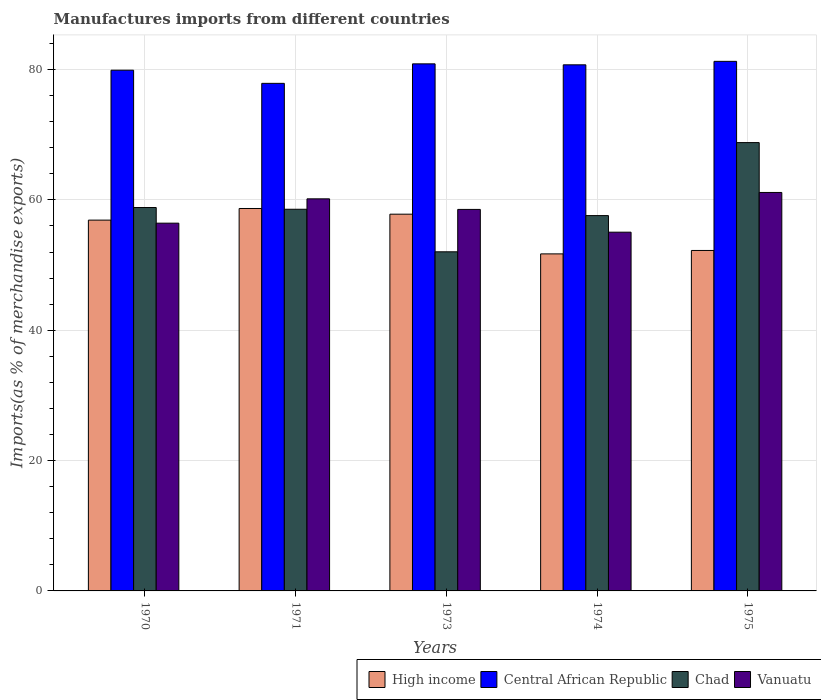How many different coloured bars are there?
Your answer should be compact. 4. Are the number of bars per tick equal to the number of legend labels?
Provide a succinct answer. Yes. How many bars are there on the 5th tick from the left?
Your answer should be compact. 4. What is the label of the 4th group of bars from the left?
Provide a short and direct response. 1974. In how many cases, is the number of bars for a given year not equal to the number of legend labels?
Give a very brief answer. 0. What is the percentage of imports to different countries in Vanuatu in 1973?
Give a very brief answer. 58.54. Across all years, what is the maximum percentage of imports to different countries in High income?
Make the answer very short. 58.69. Across all years, what is the minimum percentage of imports to different countries in Vanuatu?
Offer a terse response. 55.05. In which year was the percentage of imports to different countries in Chad maximum?
Give a very brief answer. 1975. What is the total percentage of imports to different countries in Central African Republic in the graph?
Your answer should be compact. 400.68. What is the difference between the percentage of imports to different countries in Central African Republic in 1973 and that in 1974?
Your answer should be compact. 0.15. What is the difference between the percentage of imports to different countries in High income in 1970 and the percentage of imports to different countries in Vanuatu in 1974?
Provide a succinct answer. 1.85. What is the average percentage of imports to different countries in Central African Republic per year?
Give a very brief answer. 80.14. In the year 1971, what is the difference between the percentage of imports to different countries in Central African Republic and percentage of imports to different countries in Vanuatu?
Make the answer very short. 17.72. In how many years, is the percentage of imports to different countries in Chad greater than 40 %?
Ensure brevity in your answer.  5. What is the ratio of the percentage of imports to different countries in Vanuatu in 1973 to that in 1975?
Provide a short and direct response. 0.96. Is the percentage of imports to different countries in Chad in 1974 less than that in 1975?
Keep it short and to the point. Yes. What is the difference between the highest and the second highest percentage of imports to different countries in High income?
Your answer should be very brief. 0.87. What is the difference between the highest and the lowest percentage of imports to different countries in Vanuatu?
Keep it short and to the point. 6.1. In how many years, is the percentage of imports to different countries in Vanuatu greater than the average percentage of imports to different countries in Vanuatu taken over all years?
Make the answer very short. 3. What does the 2nd bar from the left in 1970 represents?
Keep it short and to the point. Central African Republic. What does the 4th bar from the right in 1971 represents?
Provide a short and direct response. High income. Are all the bars in the graph horizontal?
Your answer should be very brief. No. How many years are there in the graph?
Make the answer very short. 5. What is the difference between two consecutive major ticks on the Y-axis?
Your answer should be very brief. 20. Does the graph contain grids?
Ensure brevity in your answer.  Yes. How many legend labels are there?
Provide a short and direct response. 4. What is the title of the graph?
Keep it short and to the point. Manufactures imports from different countries. Does "Middle income" appear as one of the legend labels in the graph?
Offer a terse response. No. What is the label or title of the Y-axis?
Your answer should be very brief. Imports(as % of merchandise exports). What is the Imports(as % of merchandise exports) in High income in 1970?
Keep it short and to the point. 56.9. What is the Imports(as % of merchandise exports) in Central African Republic in 1970?
Offer a very short reply. 79.91. What is the Imports(as % of merchandise exports) in Chad in 1970?
Give a very brief answer. 58.84. What is the Imports(as % of merchandise exports) of Vanuatu in 1970?
Provide a short and direct response. 56.43. What is the Imports(as % of merchandise exports) in High income in 1971?
Provide a short and direct response. 58.69. What is the Imports(as % of merchandise exports) of Central African Republic in 1971?
Keep it short and to the point. 77.89. What is the Imports(as % of merchandise exports) of Chad in 1971?
Give a very brief answer. 58.57. What is the Imports(as % of merchandise exports) in Vanuatu in 1971?
Your response must be concise. 60.17. What is the Imports(as % of merchandise exports) of High income in 1973?
Your answer should be very brief. 57.81. What is the Imports(as % of merchandise exports) of Central African Republic in 1973?
Offer a very short reply. 80.88. What is the Imports(as % of merchandise exports) of Chad in 1973?
Offer a very short reply. 52.04. What is the Imports(as % of merchandise exports) in Vanuatu in 1973?
Your answer should be compact. 58.54. What is the Imports(as % of merchandise exports) of High income in 1974?
Your answer should be very brief. 51.72. What is the Imports(as % of merchandise exports) in Central African Republic in 1974?
Your answer should be compact. 80.73. What is the Imports(as % of merchandise exports) in Chad in 1974?
Your answer should be compact. 57.59. What is the Imports(as % of merchandise exports) in Vanuatu in 1974?
Give a very brief answer. 55.05. What is the Imports(as % of merchandise exports) of High income in 1975?
Your answer should be compact. 52.24. What is the Imports(as % of merchandise exports) in Central African Republic in 1975?
Your answer should be compact. 81.27. What is the Imports(as % of merchandise exports) in Chad in 1975?
Provide a short and direct response. 68.8. What is the Imports(as % of merchandise exports) of Vanuatu in 1975?
Keep it short and to the point. 61.15. Across all years, what is the maximum Imports(as % of merchandise exports) of High income?
Provide a short and direct response. 58.69. Across all years, what is the maximum Imports(as % of merchandise exports) of Central African Republic?
Your answer should be very brief. 81.27. Across all years, what is the maximum Imports(as % of merchandise exports) in Chad?
Ensure brevity in your answer.  68.8. Across all years, what is the maximum Imports(as % of merchandise exports) in Vanuatu?
Provide a short and direct response. 61.15. Across all years, what is the minimum Imports(as % of merchandise exports) of High income?
Make the answer very short. 51.72. Across all years, what is the minimum Imports(as % of merchandise exports) of Central African Republic?
Make the answer very short. 77.89. Across all years, what is the minimum Imports(as % of merchandise exports) of Chad?
Offer a terse response. 52.04. Across all years, what is the minimum Imports(as % of merchandise exports) of Vanuatu?
Provide a short and direct response. 55.05. What is the total Imports(as % of merchandise exports) of High income in the graph?
Provide a succinct answer. 277.37. What is the total Imports(as % of merchandise exports) of Central African Republic in the graph?
Your response must be concise. 400.68. What is the total Imports(as % of merchandise exports) in Chad in the graph?
Provide a short and direct response. 295.84. What is the total Imports(as % of merchandise exports) of Vanuatu in the graph?
Your answer should be very brief. 291.34. What is the difference between the Imports(as % of merchandise exports) of High income in 1970 and that in 1971?
Provide a short and direct response. -1.78. What is the difference between the Imports(as % of merchandise exports) of Central African Republic in 1970 and that in 1971?
Make the answer very short. 2.02. What is the difference between the Imports(as % of merchandise exports) of Chad in 1970 and that in 1971?
Offer a very short reply. 0.27. What is the difference between the Imports(as % of merchandise exports) in Vanuatu in 1970 and that in 1971?
Your answer should be very brief. -3.73. What is the difference between the Imports(as % of merchandise exports) in High income in 1970 and that in 1973?
Your answer should be compact. -0.91. What is the difference between the Imports(as % of merchandise exports) in Central African Republic in 1970 and that in 1973?
Make the answer very short. -0.97. What is the difference between the Imports(as % of merchandise exports) of Chad in 1970 and that in 1973?
Make the answer very short. 6.8. What is the difference between the Imports(as % of merchandise exports) of Vanuatu in 1970 and that in 1973?
Keep it short and to the point. -2.11. What is the difference between the Imports(as % of merchandise exports) in High income in 1970 and that in 1974?
Your answer should be very brief. 5.18. What is the difference between the Imports(as % of merchandise exports) in Central African Republic in 1970 and that in 1974?
Make the answer very short. -0.82. What is the difference between the Imports(as % of merchandise exports) of Chad in 1970 and that in 1974?
Your answer should be very brief. 1.24. What is the difference between the Imports(as % of merchandise exports) in Vanuatu in 1970 and that in 1974?
Your answer should be compact. 1.38. What is the difference between the Imports(as % of merchandise exports) in High income in 1970 and that in 1975?
Ensure brevity in your answer.  4.66. What is the difference between the Imports(as % of merchandise exports) in Central African Republic in 1970 and that in 1975?
Your response must be concise. -1.36. What is the difference between the Imports(as % of merchandise exports) in Chad in 1970 and that in 1975?
Give a very brief answer. -9.96. What is the difference between the Imports(as % of merchandise exports) in Vanuatu in 1970 and that in 1975?
Your response must be concise. -4.71. What is the difference between the Imports(as % of merchandise exports) of High income in 1971 and that in 1973?
Your answer should be compact. 0.87. What is the difference between the Imports(as % of merchandise exports) of Central African Republic in 1971 and that in 1973?
Offer a very short reply. -2.99. What is the difference between the Imports(as % of merchandise exports) in Chad in 1971 and that in 1973?
Make the answer very short. 6.53. What is the difference between the Imports(as % of merchandise exports) in Vanuatu in 1971 and that in 1973?
Ensure brevity in your answer.  1.62. What is the difference between the Imports(as % of merchandise exports) of High income in 1971 and that in 1974?
Keep it short and to the point. 6.97. What is the difference between the Imports(as % of merchandise exports) in Central African Republic in 1971 and that in 1974?
Your response must be concise. -2.84. What is the difference between the Imports(as % of merchandise exports) in Chad in 1971 and that in 1974?
Provide a short and direct response. 0.97. What is the difference between the Imports(as % of merchandise exports) in Vanuatu in 1971 and that in 1974?
Your answer should be very brief. 5.12. What is the difference between the Imports(as % of merchandise exports) of High income in 1971 and that in 1975?
Make the answer very short. 6.44. What is the difference between the Imports(as % of merchandise exports) in Central African Republic in 1971 and that in 1975?
Provide a short and direct response. -3.38. What is the difference between the Imports(as % of merchandise exports) of Chad in 1971 and that in 1975?
Make the answer very short. -10.23. What is the difference between the Imports(as % of merchandise exports) of Vanuatu in 1971 and that in 1975?
Provide a short and direct response. -0.98. What is the difference between the Imports(as % of merchandise exports) of High income in 1973 and that in 1974?
Provide a succinct answer. 6.09. What is the difference between the Imports(as % of merchandise exports) in Central African Republic in 1973 and that in 1974?
Offer a terse response. 0.15. What is the difference between the Imports(as % of merchandise exports) of Chad in 1973 and that in 1974?
Offer a terse response. -5.55. What is the difference between the Imports(as % of merchandise exports) of Vanuatu in 1973 and that in 1974?
Give a very brief answer. 3.49. What is the difference between the Imports(as % of merchandise exports) in High income in 1973 and that in 1975?
Your answer should be compact. 5.57. What is the difference between the Imports(as % of merchandise exports) of Central African Republic in 1973 and that in 1975?
Make the answer very short. -0.38. What is the difference between the Imports(as % of merchandise exports) in Chad in 1973 and that in 1975?
Offer a very short reply. -16.76. What is the difference between the Imports(as % of merchandise exports) of Vanuatu in 1973 and that in 1975?
Offer a terse response. -2.6. What is the difference between the Imports(as % of merchandise exports) in High income in 1974 and that in 1975?
Give a very brief answer. -0.53. What is the difference between the Imports(as % of merchandise exports) of Central African Republic in 1974 and that in 1975?
Your answer should be very brief. -0.53. What is the difference between the Imports(as % of merchandise exports) of Chad in 1974 and that in 1975?
Provide a short and direct response. -11.2. What is the difference between the Imports(as % of merchandise exports) in Vanuatu in 1974 and that in 1975?
Your answer should be very brief. -6.1. What is the difference between the Imports(as % of merchandise exports) in High income in 1970 and the Imports(as % of merchandise exports) in Central African Republic in 1971?
Your response must be concise. -20.99. What is the difference between the Imports(as % of merchandise exports) in High income in 1970 and the Imports(as % of merchandise exports) in Chad in 1971?
Keep it short and to the point. -1.67. What is the difference between the Imports(as % of merchandise exports) in High income in 1970 and the Imports(as % of merchandise exports) in Vanuatu in 1971?
Provide a succinct answer. -3.26. What is the difference between the Imports(as % of merchandise exports) of Central African Republic in 1970 and the Imports(as % of merchandise exports) of Chad in 1971?
Your answer should be very brief. 21.34. What is the difference between the Imports(as % of merchandise exports) in Central African Republic in 1970 and the Imports(as % of merchandise exports) in Vanuatu in 1971?
Give a very brief answer. 19.74. What is the difference between the Imports(as % of merchandise exports) in Chad in 1970 and the Imports(as % of merchandise exports) in Vanuatu in 1971?
Provide a short and direct response. -1.33. What is the difference between the Imports(as % of merchandise exports) in High income in 1970 and the Imports(as % of merchandise exports) in Central African Republic in 1973?
Your answer should be compact. -23.98. What is the difference between the Imports(as % of merchandise exports) of High income in 1970 and the Imports(as % of merchandise exports) of Chad in 1973?
Keep it short and to the point. 4.86. What is the difference between the Imports(as % of merchandise exports) in High income in 1970 and the Imports(as % of merchandise exports) in Vanuatu in 1973?
Ensure brevity in your answer.  -1.64. What is the difference between the Imports(as % of merchandise exports) in Central African Republic in 1970 and the Imports(as % of merchandise exports) in Chad in 1973?
Provide a short and direct response. 27.87. What is the difference between the Imports(as % of merchandise exports) in Central African Republic in 1970 and the Imports(as % of merchandise exports) in Vanuatu in 1973?
Provide a short and direct response. 21.37. What is the difference between the Imports(as % of merchandise exports) of Chad in 1970 and the Imports(as % of merchandise exports) of Vanuatu in 1973?
Your answer should be compact. 0.29. What is the difference between the Imports(as % of merchandise exports) in High income in 1970 and the Imports(as % of merchandise exports) in Central African Republic in 1974?
Provide a short and direct response. -23.83. What is the difference between the Imports(as % of merchandise exports) of High income in 1970 and the Imports(as % of merchandise exports) of Chad in 1974?
Provide a short and direct response. -0.69. What is the difference between the Imports(as % of merchandise exports) in High income in 1970 and the Imports(as % of merchandise exports) in Vanuatu in 1974?
Provide a succinct answer. 1.85. What is the difference between the Imports(as % of merchandise exports) of Central African Republic in 1970 and the Imports(as % of merchandise exports) of Chad in 1974?
Make the answer very short. 22.31. What is the difference between the Imports(as % of merchandise exports) of Central African Republic in 1970 and the Imports(as % of merchandise exports) of Vanuatu in 1974?
Make the answer very short. 24.86. What is the difference between the Imports(as % of merchandise exports) of Chad in 1970 and the Imports(as % of merchandise exports) of Vanuatu in 1974?
Offer a very short reply. 3.79. What is the difference between the Imports(as % of merchandise exports) in High income in 1970 and the Imports(as % of merchandise exports) in Central African Republic in 1975?
Your response must be concise. -24.36. What is the difference between the Imports(as % of merchandise exports) of High income in 1970 and the Imports(as % of merchandise exports) of Chad in 1975?
Provide a succinct answer. -11.89. What is the difference between the Imports(as % of merchandise exports) of High income in 1970 and the Imports(as % of merchandise exports) of Vanuatu in 1975?
Provide a short and direct response. -4.24. What is the difference between the Imports(as % of merchandise exports) of Central African Republic in 1970 and the Imports(as % of merchandise exports) of Chad in 1975?
Your response must be concise. 11.11. What is the difference between the Imports(as % of merchandise exports) of Central African Republic in 1970 and the Imports(as % of merchandise exports) of Vanuatu in 1975?
Make the answer very short. 18.76. What is the difference between the Imports(as % of merchandise exports) in Chad in 1970 and the Imports(as % of merchandise exports) in Vanuatu in 1975?
Your answer should be compact. -2.31. What is the difference between the Imports(as % of merchandise exports) in High income in 1971 and the Imports(as % of merchandise exports) in Central African Republic in 1973?
Provide a short and direct response. -22.2. What is the difference between the Imports(as % of merchandise exports) of High income in 1971 and the Imports(as % of merchandise exports) of Chad in 1973?
Your response must be concise. 6.65. What is the difference between the Imports(as % of merchandise exports) of High income in 1971 and the Imports(as % of merchandise exports) of Vanuatu in 1973?
Give a very brief answer. 0.14. What is the difference between the Imports(as % of merchandise exports) in Central African Republic in 1971 and the Imports(as % of merchandise exports) in Chad in 1973?
Give a very brief answer. 25.85. What is the difference between the Imports(as % of merchandise exports) in Central African Republic in 1971 and the Imports(as % of merchandise exports) in Vanuatu in 1973?
Give a very brief answer. 19.35. What is the difference between the Imports(as % of merchandise exports) in Chad in 1971 and the Imports(as % of merchandise exports) in Vanuatu in 1973?
Your answer should be compact. 0.03. What is the difference between the Imports(as % of merchandise exports) of High income in 1971 and the Imports(as % of merchandise exports) of Central African Republic in 1974?
Make the answer very short. -22.05. What is the difference between the Imports(as % of merchandise exports) in High income in 1971 and the Imports(as % of merchandise exports) in Chad in 1974?
Your answer should be compact. 1.09. What is the difference between the Imports(as % of merchandise exports) in High income in 1971 and the Imports(as % of merchandise exports) in Vanuatu in 1974?
Your answer should be very brief. 3.64. What is the difference between the Imports(as % of merchandise exports) of Central African Republic in 1971 and the Imports(as % of merchandise exports) of Chad in 1974?
Ensure brevity in your answer.  20.29. What is the difference between the Imports(as % of merchandise exports) of Central African Republic in 1971 and the Imports(as % of merchandise exports) of Vanuatu in 1974?
Provide a short and direct response. 22.84. What is the difference between the Imports(as % of merchandise exports) of Chad in 1971 and the Imports(as % of merchandise exports) of Vanuatu in 1974?
Provide a short and direct response. 3.52. What is the difference between the Imports(as % of merchandise exports) of High income in 1971 and the Imports(as % of merchandise exports) of Central African Republic in 1975?
Provide a short and direct response. -22.58. What is the difference between the Imports(as % of merchandise exports) of High income in 1971 and the Imports(as % of merchandise exports) of Chad in 1975?
Provide a short and direct response. -10.11. What is the difference between the Imports(as % of merchandise exports) of High income in 1971 and the Imports(as % of merchandise exports) of Vanuatu in 1975?
Make the answer very short. -2.46. What is the difference between the Imports(as % of merchandise exports) of Central African Republic in 1971 and the Imports(as % of merchandise exports) of Chad in 1975?
Offer a very short reply. 9.09. What is the difference between the Imports(as % of merchandise exports) of Central African Republic in 1971 and the Imports(as % of merchandise exports) of Vanuatu in 1975?
Offer a terse response. 16.74. What is the difference between the Imports(as % of merchandise exports) in Chad in 1971 and the Imports(as % of merchandise exports) in Vanuatu in 1975?
Your response must be concise. -2.58. What is the difference between the Imports(as % of merchandise exports) in High income in 1973 and the Imports(as % of merchandise exports) in Central African Republic in 1974?
Offer a terse response. -22.92. What is the difference between the Imports(as % of merchandise exports) of High income in 1973 and the Imports(as % of merchandise exports) of Chad in 1974?
Your answer should be compact. 0.22. What is the difference between the Imports(as % of merchandise exports) in High income in 1973 and the Imports(as % of merchandise exports) in Vanuatu in 1974?
Make the answer very short. 2.76. What is the difference between the Imports(as % of merchandise exports) of Central African Republic in 1973 and the Imports(as % of merchandise exports) of Chad in 1974?
Provide a short and direct response. 23.29. What is the difference between the Imports(as % of merchandise exports) in Central African Republic in 1973 and the Imports(as % of merchandise exports) in Vanuatu in 1974?
Offer a very short reply. 25.83. What is the difference between the Imports(as % of merchandise exports) of Chad in 1973 and the Imports(as % of merchandise exports) of Vanuatu in 1974?
Give a very brief answer. -3.01. What is the difference between the Imports(as % of merchandise exports) in High income in 1973 and the Imports(as % of merchandise exports) in Central African Republic in 1975?
Ensure brevity in your answer.  -23.45. What is the difference between the Imports(as % of merchandise exports) of High income in 1973 and the Imports(as % of merchandise exports) of Chad in 1975?
Offer a very short reply. -10.98. What is the difference between the Imports(as % of merchandise exports) in High income in 1973 and the Imports(as % of merchandise exports) in Vanuatu in 1975?
Provide a short and direct response. -3.33. What is the difference between the Imports(as % of merchandise exports) in Central African Republic in 1973 and the Imports(as % of merchandise exports) in Chad in 1975?
Provide a short and direct response. 12.08. What is the difference between the Imports(as % of merchandise exports) in Central African Republic in 1973 and the Imports(as % of merchandise exports) in Vanuatu in 1975?
Give a very brief answer. 19.74. What is the difference between the Imports(as % of merchandise exports) of Chad in 1973 and the Imports(as % of merchandise exports) of Vanuatu in 1975?
Keep it short and to the point. -9.11. What is the difference between the Imports(as % of merchandise exports) in High income in 1974 and the Imports(as % of merchandise exports) in Central African Republic in 1975?
Give a very brief answer. -29.55. What is the difference between the Imports(as % of merchandise exports) of High income in 1974 and the Imports(as % of merchandise exports) of Chad in 1975?
Make the answer very short. -17.08. What is the difference between the Imports(as % of merchandise exports) of High income in 1974 and the Imports(as % of merchandise exports) of Vanuatu in 1975?
Provide a succinct answer. -9.43. What is the difference between the Imports(as % of merchandise exports) in Central African Republic in 1974 and the Imports(as % of merchandise exports) in Chad in 1975?
Provide a short and direct response. 11.94. What is the difference between the Imports(as % of merchandise exports) in Central African Republic in 1974 and the Imports(as % of merchandise exports) in Vanuatu in 1975?
Your answer should be compact. 19.59. What is the difference between the Imports(as % of merchandise exports) in Chad in 1974 and the Imports(as % of merchandise exports) in Vanuatu in 1975?
Offer a very short reply. -3.55. What is the average Imports(as % of merchandise exports) of High income per year?
Your answer should be compact. 55.47. What is the average Imports(as % of merchandise exports) of Central African Republic per year?
Ensure brevity in your answer.  80.14. What is the average Imports(as % of merchandise exports) in Chad per year?
Offer a terse response. 59.17. What is the average Imports(as % of merchandise exports) of Vanuatu per year?
Offer a very short reply. 58.27. In the year 1970, what is the difference between the Imports(as % of merchandise exports) of High income and Imports(as % of merchandise exports) of Central African Republic?
Your answer should be compact. -23.01. In the year 1970, what is the difference between the Imports(as % of merchandise exports) of High income and Imports(as % of merchandise exports) of Chad?
Provide a short and direct response. -1.93. In the year 1970, what is the difference between the Imports(as % of merchandise exports) in High income and Imports(as % of merchandise exports) in Vanuatu?
Keep it short and to the point. 0.47. In the year 1970, what is the difference between the Imports(as % of merchandise exports) of Central African Republic and Imports(as % of merchandise exports) of Chad?
Your answer should be compact. 21.07. In the year 1970, what is the difference between the Imports(as % of merchandise exports) of Central African Republic and Imports(as % of merchandise exports) of Vanuatu?
Offer a very short reply. 23.48. In the year 1970, what is the difference between the Imports(as % of merchandise exports) in Chad and Imports(as % of merchandise exports) in Vanuatu?
Ensure brevity in your answer.  2.4. In the year 1971, what is the difference between the Imports(as % of merchandise exports) in High income and Imports(as % of merchandise exports) in Central African Republic?
Offer a very short reply. -19.2. In the year 1971, what is the difference between the Imports(as % of merchandise exports) of High income and Imports(as % of merchandise exports) of Chad?
Keep it short and to the point. 0.12. In the year 1971, what is the difference between the Imports(as % of merchandise exports) in High income and Imports(as % of merchandise exports) in Vanuatu?
Offer a terse response. -1.48. In the year 1971, what is the difference between the Imports(as % of merchandise exports) of Central African Republic and Imports(as % of merchandise exports) of Chad?
Your response must be concise. 19.32. In the year 1971, what is the difference between the Imports(as % of merchandise exports) of Central African Republic and Imports(as % of merchandise exports) of Vanuatu?
Your answer should be compact. 17.72. In the year 1971, what is the difference between the Imports(as % of merchandise exports) in Chad and Imports(as % of merchandise exports) in Vanuatu?
Offer a very short reply. -1.6. In the year 1973, what is the difference between the Imports(as % of merchandise exports) of High income and Imports(as % of merchandise exports) of Central African Republic?
Offer a very short reply. -23.07. In the year 1973, what is the difference between the Imports(as % of merchandise exports) of High income and Imports(as % of merchandise exports) of Chad?
Your answer should be compact. 5.77. In the year 1973, what is the difference between the Imports(as % of merchandise exports) in High income and Imports(as % of merchandise exports) in Vanuatu?
Your response must be concise. -0.73. In the year 1973, what is the difference between the Imports(as % of merchandise exports) in Central African Republic and Imports(as % of merchandise exports) in Chad?
Ensure brevity in your answer.  28.84. In the year 1973, what is the difference between the Imports(as % of merchandise exports) in Central African Republic and Imports(as % of merchandise exports) in Vanuatu?
Offer a terse response. 22.34. In the year 1973, what is the difference between the Imports(as % of merchandise exports) of Chad and Imports(as % of merchandise exports) of Vanuatu?
Give a very brief answer. -6.5. In the year 1974, what is the difference between the Imports(as % of merchandise exports) of High income and Imports(as % of merchandise exports) of Central African Republic?
Keep it short and to the point. -29.01. In the year 1974, what is the difference between the Imports(as % of merchandise exports) in High income and Imports(as % of merchandise exports) in Chad?
Your answer should be very brief. -5.88. In the year 1974, what is the difference between the Imports(as % of merchandise exports) in High income and Imports(as % of merchandise exports) in Vanuatu?
Give a very brief answer. -3.33. In the year 1974, what is the difference between the Imports(as % of merchandise exports) in Central African Republic and Imports(as % of merchandise exports) in Chad?
Keep it short and to the point. 23.14. In the year 1974, what is the difference between the Imports(as % of merchandise exports) in Central African Republic and Imports(as % of merchandise exports) in Vanuatu?
Offer a very short reply. 25.68. In the year 1974, what is the difference between the Imports(as % of merchandise exports) of Chad and Imports(as % of merchandise exports) of Vanuatu?
Your response must be concise. 2.54. In the year 1975, what is the difference between the Imports(as % of merchandise exports) in High income and Imports(as % of merchandise exports) in Central African Republic?
Offer a terse response. -29.02. In the year 1975, what is the difference between the Imports(as % of merchandise exports) of High income and Imports(as % of merchandise exports) of Chad?
Offer a terse response. -16.55. In the year 1975, what is the difference between the Imports(as % of merchandise exports) of High income and Imports(as % of merchandise exports) of Vanuatu?
Ensure brevity in your answer.  -8.9. In the year 1975, what is the difference between the Imports(as % of merchandise exports) of Central African Republic and Imports(as % of merchandise exports) of Chad?
Your response must be concise. 12.47. In the year 1975, what is the difference between the Imports(as % of merchandise exports) of Central African Republic and Imports(as % of merchandise exports) of Vanuatu?
Your answer should be compact. 20.12. In the year 1975, what is the difference between the Imports(as % of merchandise exports) in Chad and Imports(as % of merchandise exports) in Vanuatu?
Your answer should be compact. 7.65. What is the ratio of the Imports(as % of merchandise exports) of High income in 1970 to that in 1971?
Your answer should be compact. 0.97. What is the ratio of the Imports(as % of merchandise exports) in Central African Republic in 1970 to that in 1971?
Make the answer very short. 1.03. What is the ratio of the Imports(as % of merchandise exports) of Vanuatu in 1970 to that in 1971?
Provide a succinct answer. 0.94. What is the ratio of the Imports(as % of merchandise exports) in High income in 1970 to that in 1973?
Make the answer very short. 0.98. What is the ratio of the Imports(as % of merchandise exports) in Chad in 1970 to that in 1973?
Ensure brevity in your answer.  1.13. What is the ratio of the Imports(as % of merchandise exports) of High income in 1970 to that in 1974?
Ensure brevity in your answer.  1.1. What is the ratio of the Imports(as % of merchandise exports) in Central African Republic in 1970 to that in 1974?
Provide a succinct answer. 0.99. What is the ratio of the Imports(as % of merchandise exports) of Chad in 1970 to that in 1974?
Make the answer very short. 1.02. What is the ratio of the Imports(as % of merchandise exports) of Vanuatu in 1970 to that in 1974?
Offer a very short reply. 1.03. What is the ratio of the Imports(as % of merchandise exports) of High income in 1970 to that in 1975?
Keep it short and to the point. 1.09. What is the ratio of the Imports(as % of merchandise exports) of Central African Republic in 1970 to that in 1975?
Make the answer very short. 0.98. What is the ratio of the Imports(as % of merchandise exports) in Chad in 1970 to that in 1975?
Your response must be concise. 0.86. What is the ratio of the Imports(as % of merchandise exports) in Vanuatu in 1970 to that in 1975?
Offer a very short reply. 0.92. What is the ratio of the Imports(as % of merchandise exports) in High income in 1971 to that in 1973?
Offer a very short reply. 1.02. What is the ratio of the Imports(as % of merchandise exports) of Central African Republic in 1971 to that in 1973?
Provide a succinct answer. 0.96. What is the ratio of the Imports(as % of merchandise exports) in Chad in 1971 to that in 1973?
Offer a terse response. 1.13. What is the ratio of the Imports(as % of merchandise exports) in Vanuatu in 1971 to that in 1973?
Ensure brevity in your answer.  1.03. What is the ratio of the Imports(as % of merchandise exports) in High income in 1971 to that in 1974?
Keep it short and to the point. 1.13. What is the ratio of the Imports(as % of merchandise exports) of Central African Republic in 1971 to that in 1974?
Give a very brief answer. 0.96. What is the ratio of the Imports(as % of merchandise exports) in Chad in 1971 to that in 1974?
Ensure brevity in your answer.  1.02. What is the ratio of the Imports(as % of merchandise exports) of Vanuatu in 1971 to that in 1974?
Your answer should be compact. 1.09. What is the ratio of the Imports(as % of merchandise exports) in High income in 1971 to that in 1975?
Ensure brevity in your answer.  1.12. What is the ratio of the Imports(as % of merchandise exports) of Central African Republic in 1971 to that in 1975?
Your response must be concise. 0.96. What is the ratio of the Imports(as % of merchandise exports) in Chad in 1971 to that in 1975?
Provide a short and direct response. 0.85. What is the ratio of the Imports(as % of merchandise exports) of Vanuatu in 1971 to that in 1975?
Ensure brevity in your answer.  0.98. What is the ratio of the Imports(as % of merchandise exports) of High income in 1973 to that in 1974?
Offer a terse response. 1.12. What is the ratio of the Imports(as % of merchandise exports) of Central African Republic in 1973 to that in 1974?
Ensure brevity in your answer.  1. What is the ratio of the Imports(as % of merchandise exports) of Chad in 1973 to that in 1974?
Ensure brevity in your answer.  0.9. What is the ratio of the Imports(as % of merchandise exports) in Vanuatu in 1973 to that in 1974?
Ensure brevity in your answer.  1.06. What is the ratio of the Imports(as % of merchandise exports) of High income in 1973 to that in 1975?
Give a very brief answer. 1.11. What is the ratio of the Imports(as % of merchandise exports) in Central African Republic in 1973 to that in 1975?
Provide a short and direct response. 1. What is the ratio of the Imports(as % of merchandise exports) in Chad in 1973 to that in 1975?
Give a very brief answer. 0.76. What is the ratio of the Imports(as % of merchandise exports) in Vanuatu in 1973 to that in 1975?
Your answer should be very brief. 0.96. What is the ratio of the Imports(as % of merchandise exports) in Central African Republic in 1974 to that in 1975?
Provide a short and direct response. 0.99. What is the ratio of the Imports(as % of merchandise exports) of Chad in 1974 to that in 1975?
Your answer should be very brief. 0.84. What is the ratio of the Imports(as % of merchandise exports) in Vanuatu in 1974 to that in 1975?
Give a very brief answer. 0.9. What is the difference between the highest and the second highest Imports(as % of merchandise exports) of High income?
Your answer should be very brief. 0.87. What is the difference between the highest and the second highest Imports(as % of merchandise exports) in Central African Republic?
Provide a short and direct response. 0.38. What is the difference between the highest and the second highest Imports(as % of merchandise exports) of Chad?
Your response must be concise. 9.96. What is the difference between the highest and the second highest Imports(as % of merchandise exports) of Vanuatu?
Your answer should be very brief. 0.98. What is the difference between the highest and the lowest Imports(as % of merchandise exports) in High income?
Your answer should be compact. 6.97. What is the difference between the highest and the lowest Imports(as % of merchandise exports) of Central African Republic?
Give a very brief answer. 3.38. What is the difference between the highest and the lowest Imports(as % of merchandise exports) of Chad?
Keep it short and to the point. 16.76. What is the difference between the highest and the lowest Imports(as % of merchandise exports) in Vanuatu?
Provide a succinct answer. 6.1. 